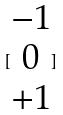<formula> <loc_0><loc_0><loc_500><loc_500>[ \begin{matrix} - 1 \\ 0 \\ + 1 \end{matrix} ]</formula> 